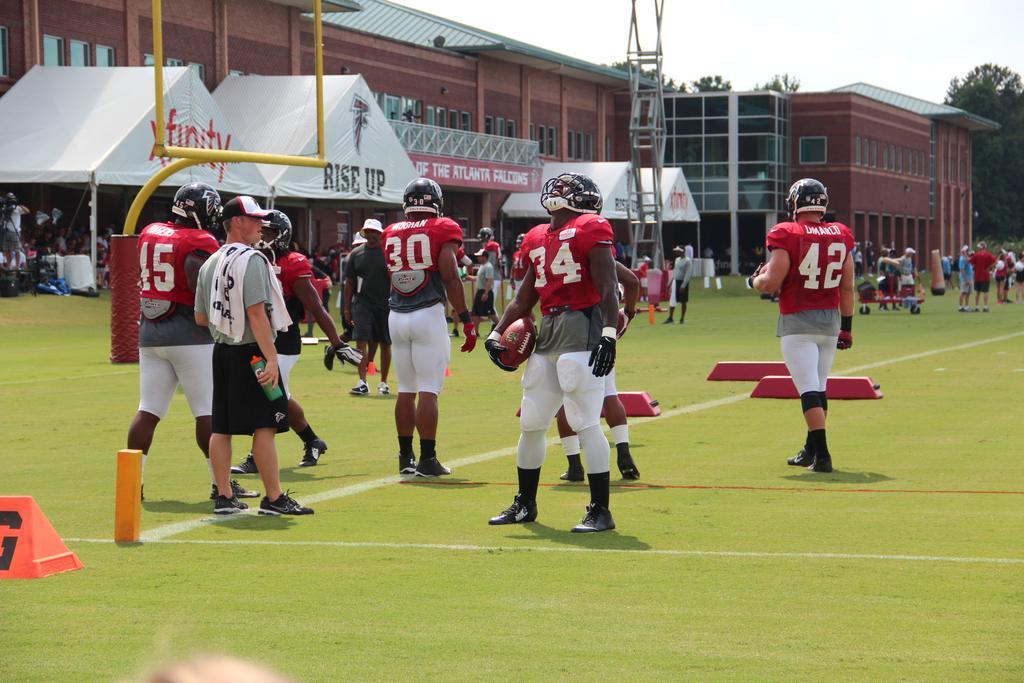Please provide a concise description of this image. In this picture we can see the buildings, sheds, rods, trolley and some people are playing and some of them are standing. In the center of the image we can see a man is standing and holding a ball. At the bottom of the image we can see the ground. At the top of the image we can see the sky. On the right side of the image we can see the trees. 